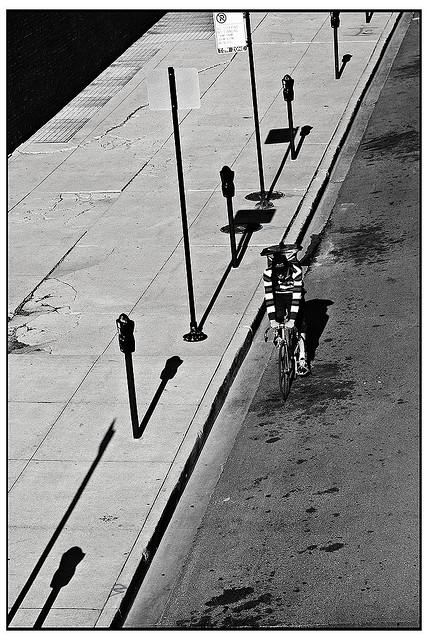What kind of vehicle is the person driving up next to the street? bicycle 